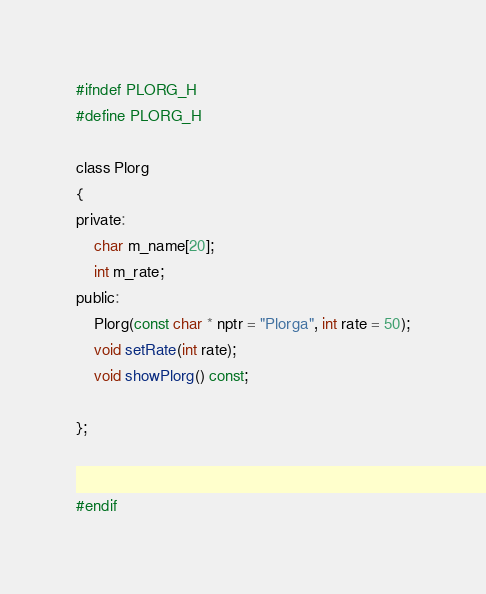Convert code to text. <code><loc_0><loc_0><loc_500><loc_500><_C_>#ifndef PLORG_H
#define PLORG_H

class Plorg
{
private:
    char m_name[20];
    int m_rate;
public:
    Plorg(const char * nptr = "Plorga", int rate = 50);
    void setRate(int rate);
    void showPlorg() const;

};


#endif
</code> 